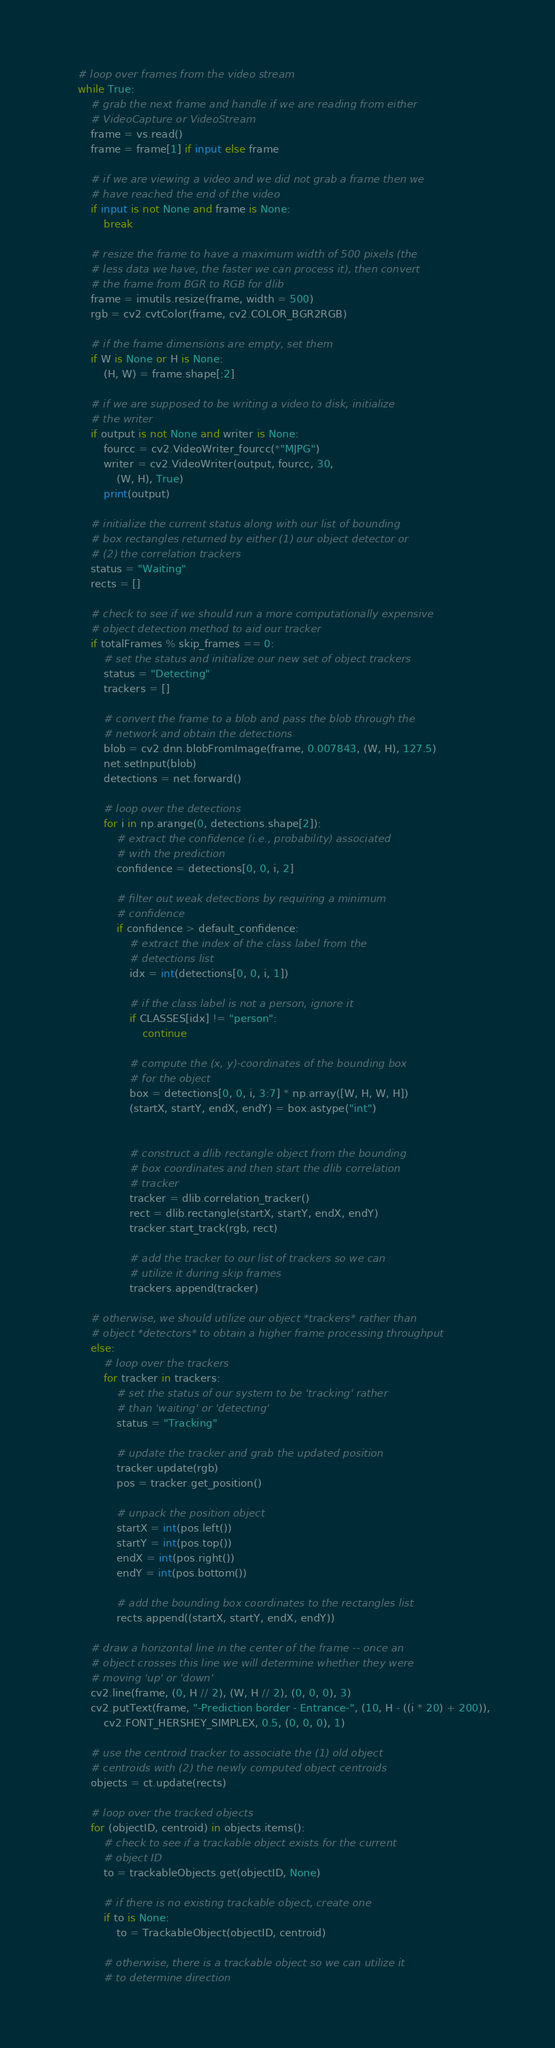<code> <loc_0><loc_0><loc_500><loc_500><_Python_>    # loop over frames from the video stream
    while True:
        # grab the next frame and handle if we are reading from either
        # VideoCapture or VideoStream
        frame = vs.read()
        frame = frame[1] if input else frame

        # if we are viewing a video and we did not grab a frame then we
        # have reached the end of the video
        if input is not None and frame is None:
            break

        # resize the frame to have a maximum width of 500 pixels (the
        # less data we have, the faster we can process it), then convert
        # the frame from BGR to RGB for dlib
        frame = imutils.resize(frame, width = 500)
        rgb = cv2.cvtColor(frame, cv2.COLOR_BGR2RGB)

        # if the frame dimensions are empty, set them
        if W is None or H is None:
            (H, W) = frame.shape[:2]

        # if we are supposed to be writing a video to disk, initialize
        # the writer
        if output is not None and writer is None:
            fourcc = cv2.VideoWriter_fourcc(*"MJPG")
            writer = cv2.VideoWriter(output, fourcc, 30,
                (W, H), True)
            print(output)

        # initialize the current status along with our list of bounding
        # box rectangles returned by either (1) our object detector or
        # (2) the correlation trackers
        status = "Waiting"
        rects = []

        # check to see if we should run a more computationally expensive
        # object detection method to aid our tracker
        if totalFrames % skip_frames == 0:
            # set the status and initialize our new set of object trackers
            status = "Detecting"
            trackers = []

            # convert the frame to a blob and pass the blob through the
            # network and obtain the detections
            blob = cv2.dnn.blobFromImage(frame, 0.007843, (W, H), 127.5)
            net.setInput(blob)
            detections = net.forward()

            # loop over the detections
            for i in np.arange(0, detections.shape[2]):
                # extract the confidence (i.e., probability) associated
                # with the prediction
                confidence = detections[0, 0, i, 2]

                # filter out weak detections by requiring a minimum
                # confidence
                if confidence > default_confidence:
                    # extract the index of the class label from the
                    # detections list
                    idx = int(detections[0, 0, i, 1])

                    # if the class label is not a person, ignore it
                    if CLASSES[idx] != "person":
                        continue

                    # compute the (x, y)-coordinates of the bounding box
                    # for the object
                    box = detections[0, 0, i, 3:7] * np.array([W, H, W, H])
                    (startX, startY, endX, endY) = box.astype("int")


                    # construct a dlib rectangle object from the bounding
                    # box coordinates and then start the dlib correlation
                    # tracker
                    tracker = dlib.correlation_tracker()
                    rect = dlib.rectangle(startX, startY, endX, endY)
                    tracker.start_track(rgb, rect)

                    # add the tracker to our list of trackers so we can
                    # utilize it during skip frames
                    trackers.append(tracker)

        # otherwise, we should utilize our object *trackers* rather than
        # object *detectors* to obtain a higher frame processing throughput
        else:
            # loop over the trackers
            for tracker in trackers:
                # set the status of our system to be 'tracking' rather
                # than 'waiting' or 'detecting'
                status = "Tracking"

                # update the tracker and grab the updated position
                tracker.update(rgb)
                pos = tracker.get_position()

                # unpack the position object
                startX = int(pos.left())
                startY = int(pos.top())
                endX = int(pos.right())
                endY = int(pos.bottom())

                # add the bounding box coordinates to the rectangles list
                rects.append((startX, startY, endX, endY))

        # draw a horizontal line in the center of the frame -- once an
        # object crosses this line we will determine whether they were
        # moving 'up' or 'down'
        cv2.line(frame, (0, H // 2), (W, H // 2), (0, 0, 0), 3)
        cv2.putText(frame, "-Prediction border - Entrance-", (10, H - ((i * 20) + 200)),
            cv2.FONT_HERSHEY_SIMPLEX, 0.5, (0, 0, 0), 1)

        # use the centroid tracker to associate the (1) old object
        # centroids with (2) the newly computed object centroids
        objects = ct.update(rects)

        # loop over the tracked objects
        for (objectID, centroid) in objects.items():
            # check to see if a trackable object exists for the current
            # object ID
            to = trackableObjects.get(objectID, None)

            # if there is no existing trackable object, create one
            if to is None:
                to = TrackableObject(objectID, centroid)

            # otherwise, there is a trackable object so we can utilize it
            # to determine direction</code> 